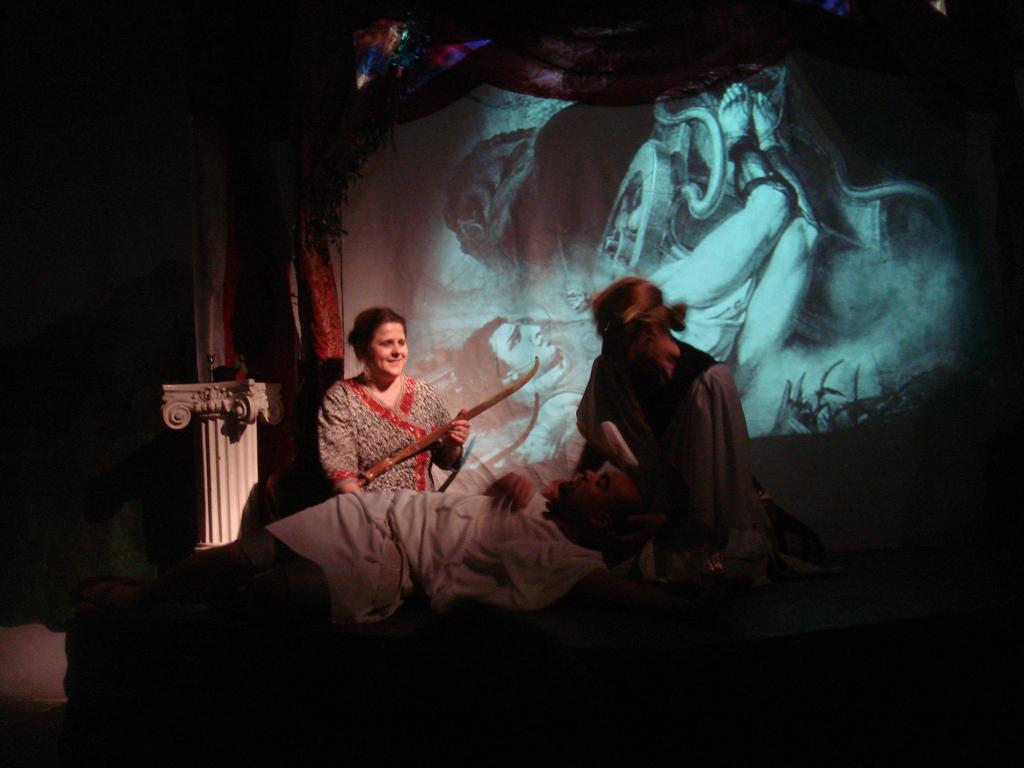In one or two sentences, can you explain what this image depicts? In this image, we can see persons wearing clothes. There is a screen in the middle of the image. There are curtains at the top of the image. 